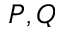Convert formula to latex. <formula><loc_0><loc_0><loc_500><loc_500>P , Q</formula> 